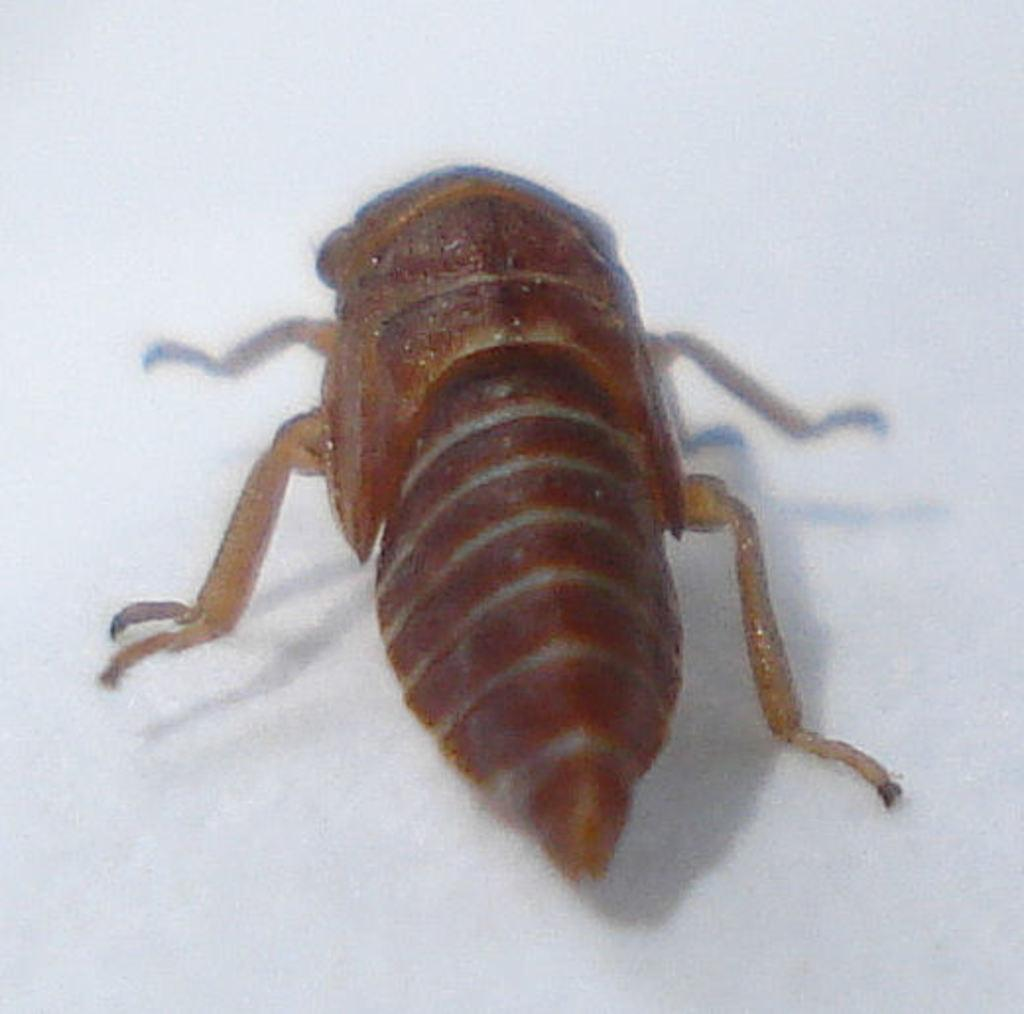What type of creature is in the picture? There is an insect in the picture. What color is the insect? The insect is brown in color. What is the background or surface the insect is on? The insect is on a white surface. What type of recess is visible in the image? There is no recess present in the image; it features an insect on a white surface. How does the insect contribute to the waste management in the image? The image does not depict any waste management or the insect's role in it. 